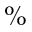Convert formula to latex. <formula><loc_0><loc_0><loc_500><loc_500>\%</formula> 